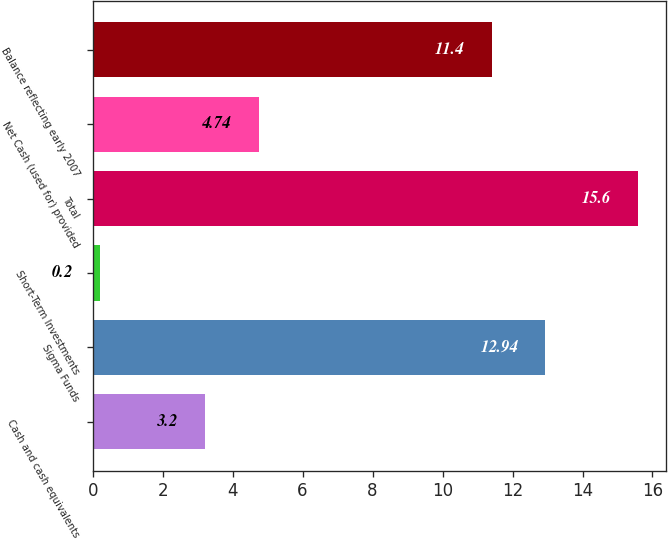Convert chart to OTSL. <chart><loc_0><loc_0><loc_500><loc_500><bar_chart><fcel>Cash and cash equivalents<fcel>Sigma Funds<fcel>Short-Term Investments<fcel>Total<fcel>Net Cash (used for) provided<fcel>Balance reflecting early 2007<nl><fcel>3.2<fcel>12.94<fcel>0.2<fcel>15.6<fcel>4.74<fcel>11.4<nl></chart> 